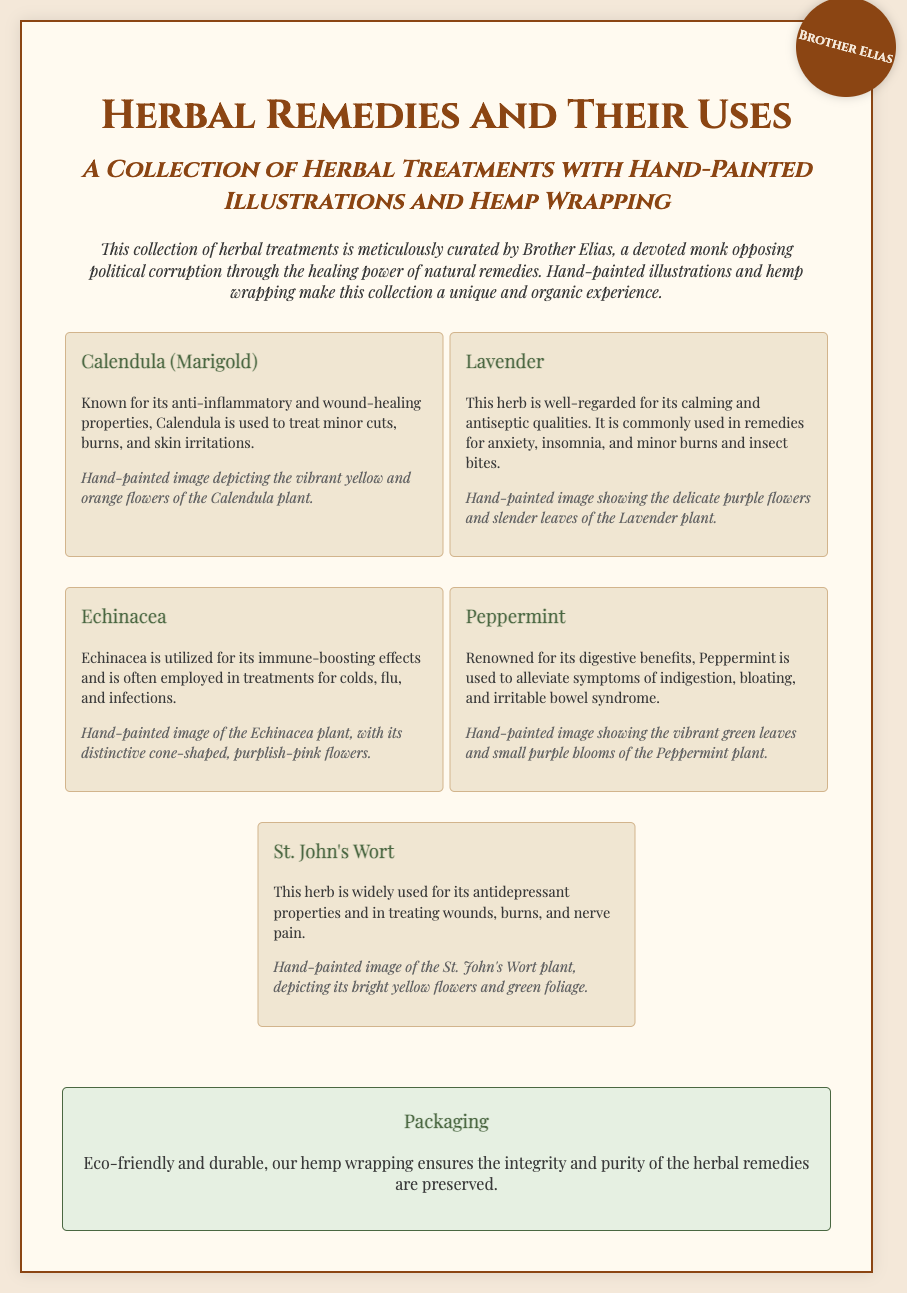What is the title of the collection? The title of the collection is prominently displayed at the top of the document, which is "Herbal Remedies and Their Uses".
Answer: Herbal Remedies and Their Uses Who is the author of the collection? The author is mentioned within the seal and introductory text as Brother Elias.
Answer: Brother Elias What herb is known for its anti-inflammatory properties? The document lists specific properties of various herbs, stating that Calendula is known for its anti-inflammatory and wound-healing properties.
Answer: Calendula What is the main purpose of Lavender according to the document? The document describes Lavender as being used for calming and antiseptic qualities which indicates its purpose.
Answer: Calming How are the herbal remedies packaged? There is a dedicated packaging section that describes how the herbal remedies are packaged eco-friendly with hemp wrapping.
Answer: Hemp wrapping Which herb is utilized for its immune-boosting effects? This information is found in the descriptions of the herbs, where Echinacea is specifically mentioned for its immune-boosting effects.
Answer: Echinacea What color is associated with the flowers of St. John's Wort? The document provides details about the plant, stating that St. John's Wort has bright yellow flowers.
Answer: Bright yellow How many herbs are listed in the collection? The document lists five specific herbs under their descriptions, providing insight into the collection size.
Answer: Five What type of illustrations accompany the collection? The document mentions that the illustrations of the herbs are hand-painted, which implies a unique artistic approach.
Answer: Hand-painted illustrations 